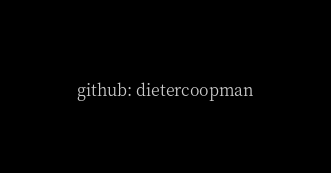<code> <loc_0><loc_0><loc_500><loc_500><_YAML_>github: dietercoopman
</code> 